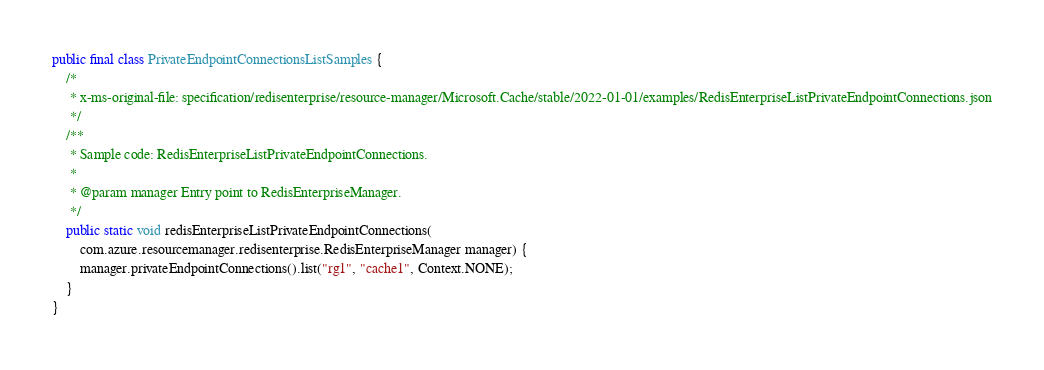Convert code to text. <code><loc_0><loc_0><loc_500><loc_500><_Java_>public final class PrivateEndpointConnectionsListSamples {
    /*
     * x-ms-original-file: specification/redisenterprise/resource-manager/Microsoft.Cache/stable/2022-01-01/examples/RedisEnterpriseListPrivateEndpointConnections.json
     */
    /**
     * Sample code: RedisEnterpriseListPrivateEndpointConnections.
     *
     * @param manager Entry point to RedisEnterpriseManager.
     */
    public static void redisEnterpriseListPrivateEndpointConnections(
        com.azure.resourcemanager.redisenterprise.RedisEnterpriseManager manager) {
        manager.privateEndpointConnections().list("rg1", "cache1", Context.NONE);
    }
}
</code> 